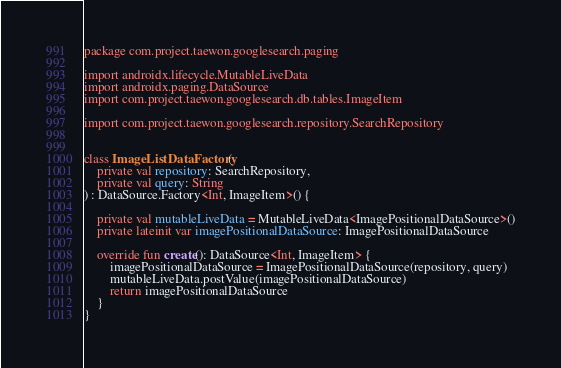<code> <loc_0><loc_0><loc_500><loc_500><_Kotlin_>package com.project.taewon.googlesearch.paging

import androidx.lifecycle.MutableLiveData
import androidx.paging.DataSource
import com.project.taewon.googlesearch.db.tables.ImageItem

import com.project.taewon.googlesearch.repository.SearchRepository


class ImageListDataFactory(
    private val repository: SearchRepository,
    private val query: String
) : DataSource.Factory<Int, ImageItem>() {

    private val mutableLiveData = MutableLiveData<ImagePositionalDataSource>()
    private lateinit var imagePositionalDataSource: ImagePositionalDataSource

    override fun create(): DataSource<Int, ImageItem> {
        imagePositionalDataSource = ImagePositionalDataSource(repository, query)
        mutableLiveData.postValue(imagePositionalDataSource)
        return imagePositionalDataSource
    }
}</code> 